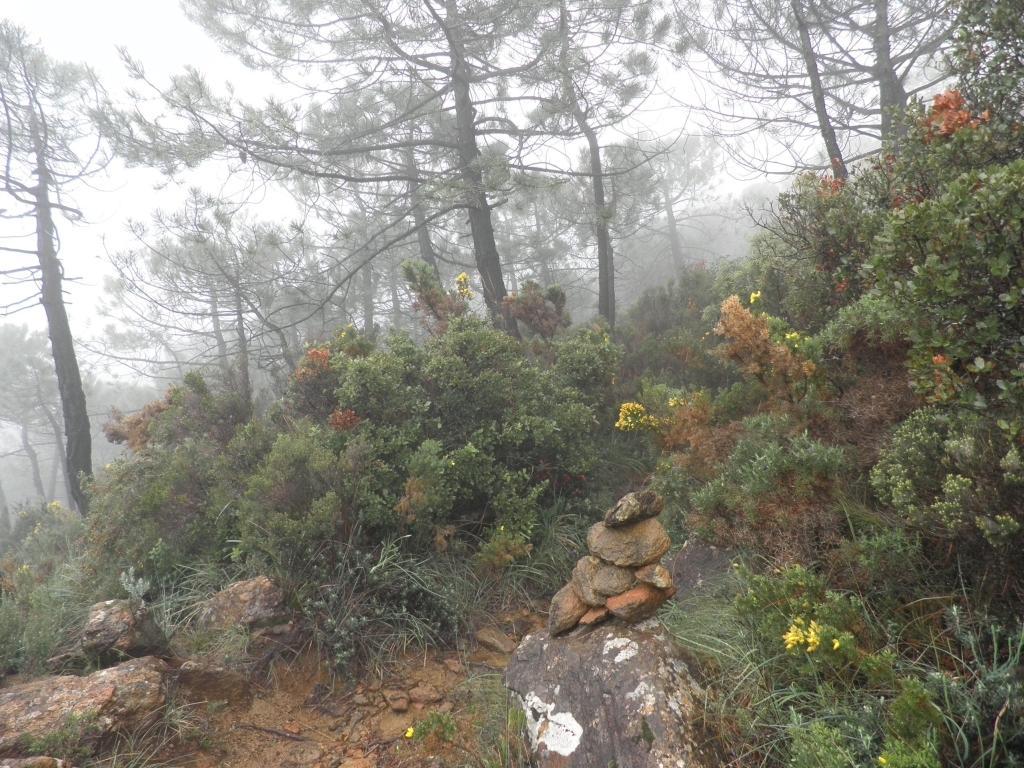Could you give a brief overview of what you see in this image? In the picture I can see some rocks, plants and in the background of the picture there are some trees, fog. 